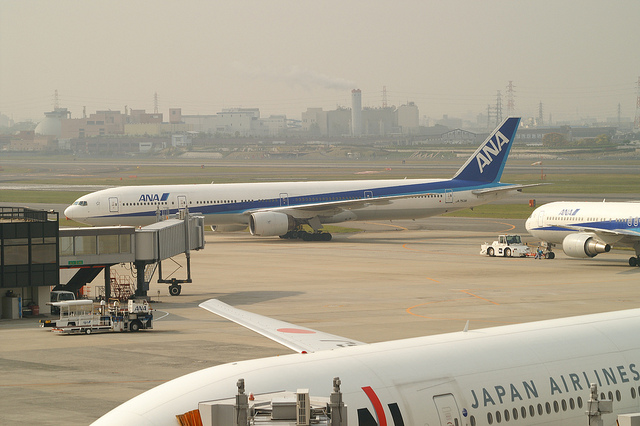Please extract the text content from this image. ANA ANA JAPAN AIRLINES ANA 